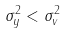Convert formula to latex. <formula><loc_0><loc_0><loc_500><loc_500>\sigma _ { y } ^ { 2 } < \sigma _ { v } ^ { 2 }</formula> 